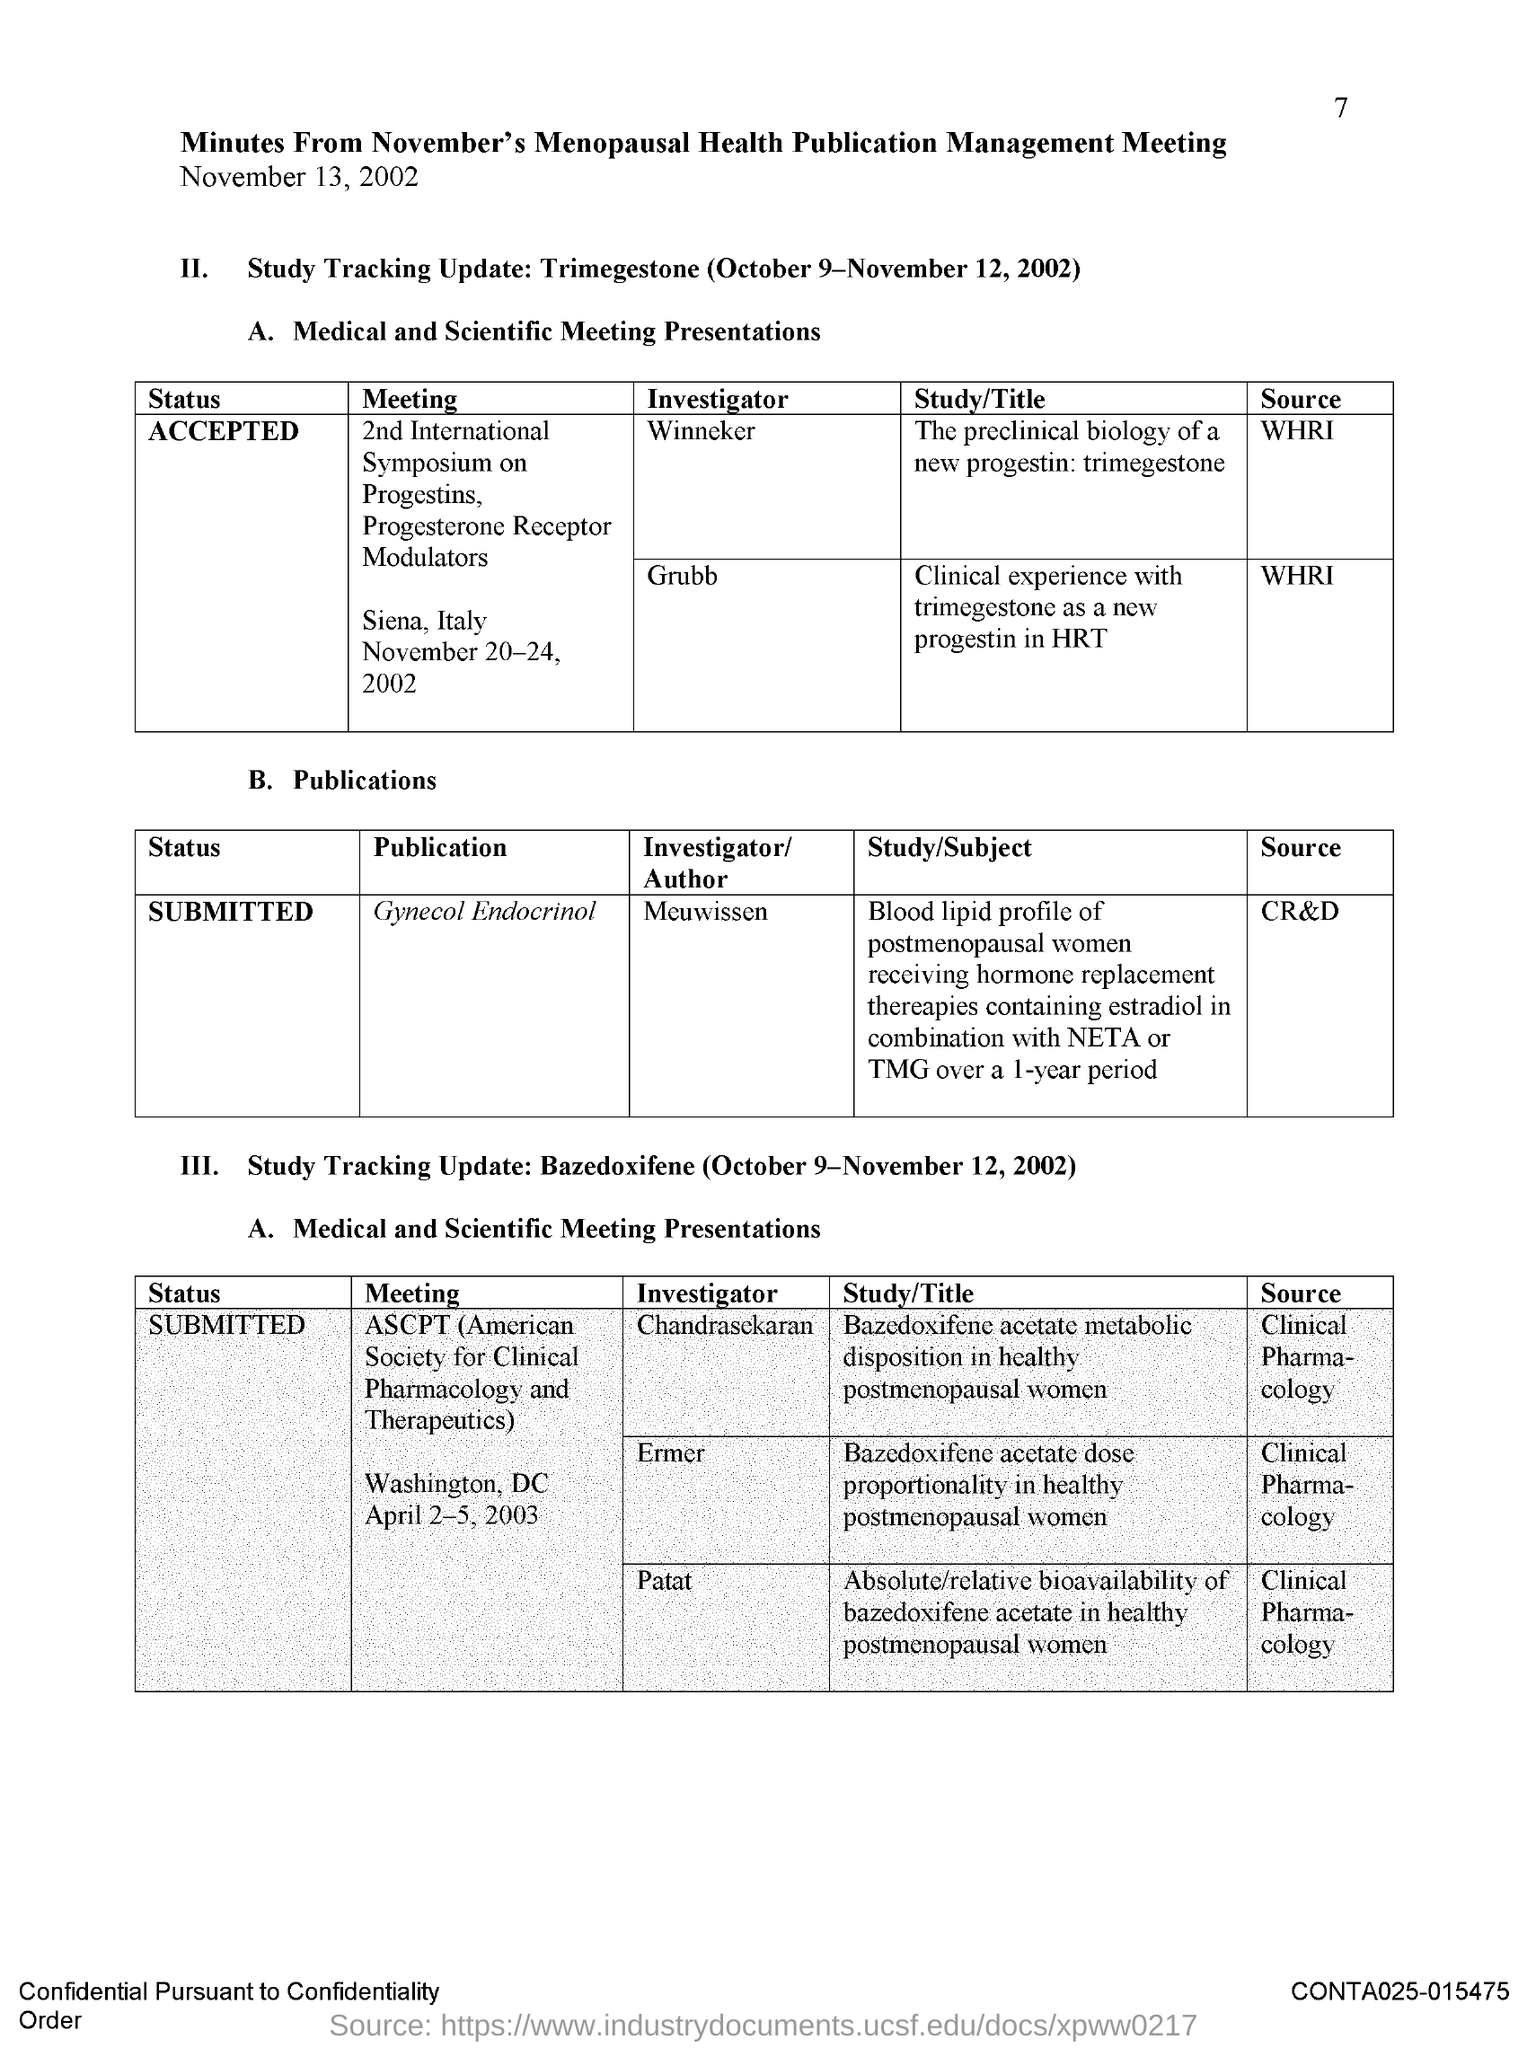Point out several critical features in this image. The 2nd International Symposium on progestins and progestin receptor modulators was held from November 20-24, 2002. Patat is an investigator for the American Society for Clinical Pharmacology and Therapeutics (ASCPT). The ASCPT meeting is held in Washington, DC. The 2nd International Symposium on progestins and progestin receptor modulators was held in Siena, Italy. Chandrasekaran is an investigator for the ASCPT (American Society for Clinical Pharmacology and Therapeutics) meeting. 